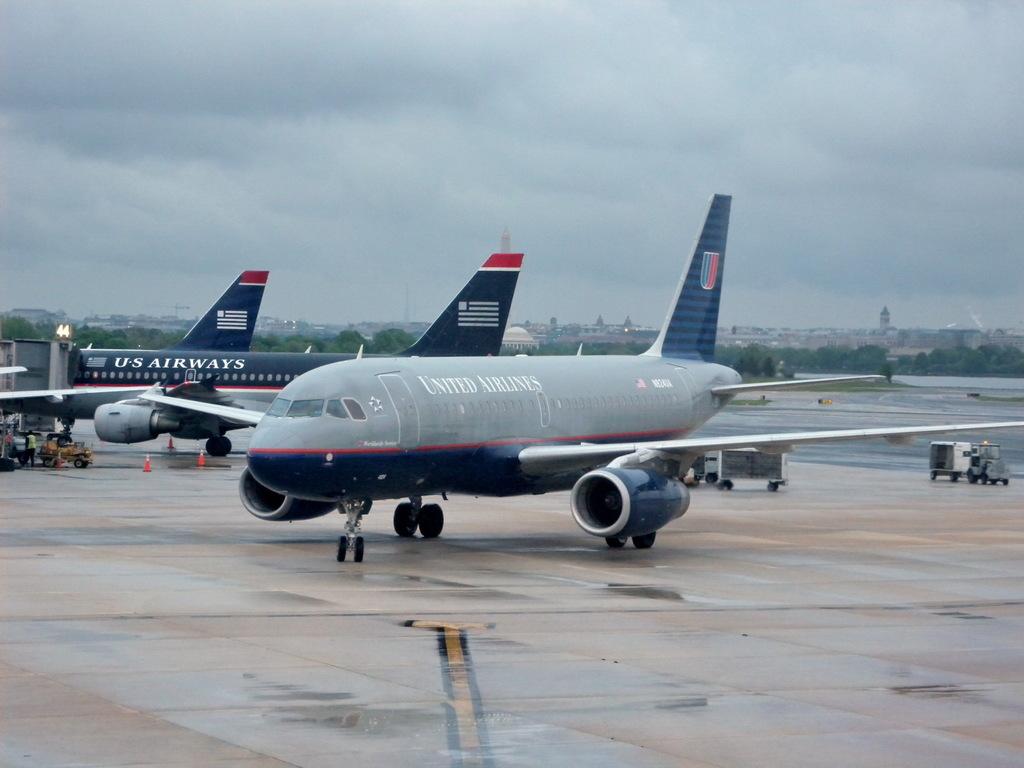What airline is shown?
Provide a short and direct response. United airlines. What is the company name on the airplane?
Give a very brief answer. United airlines. 